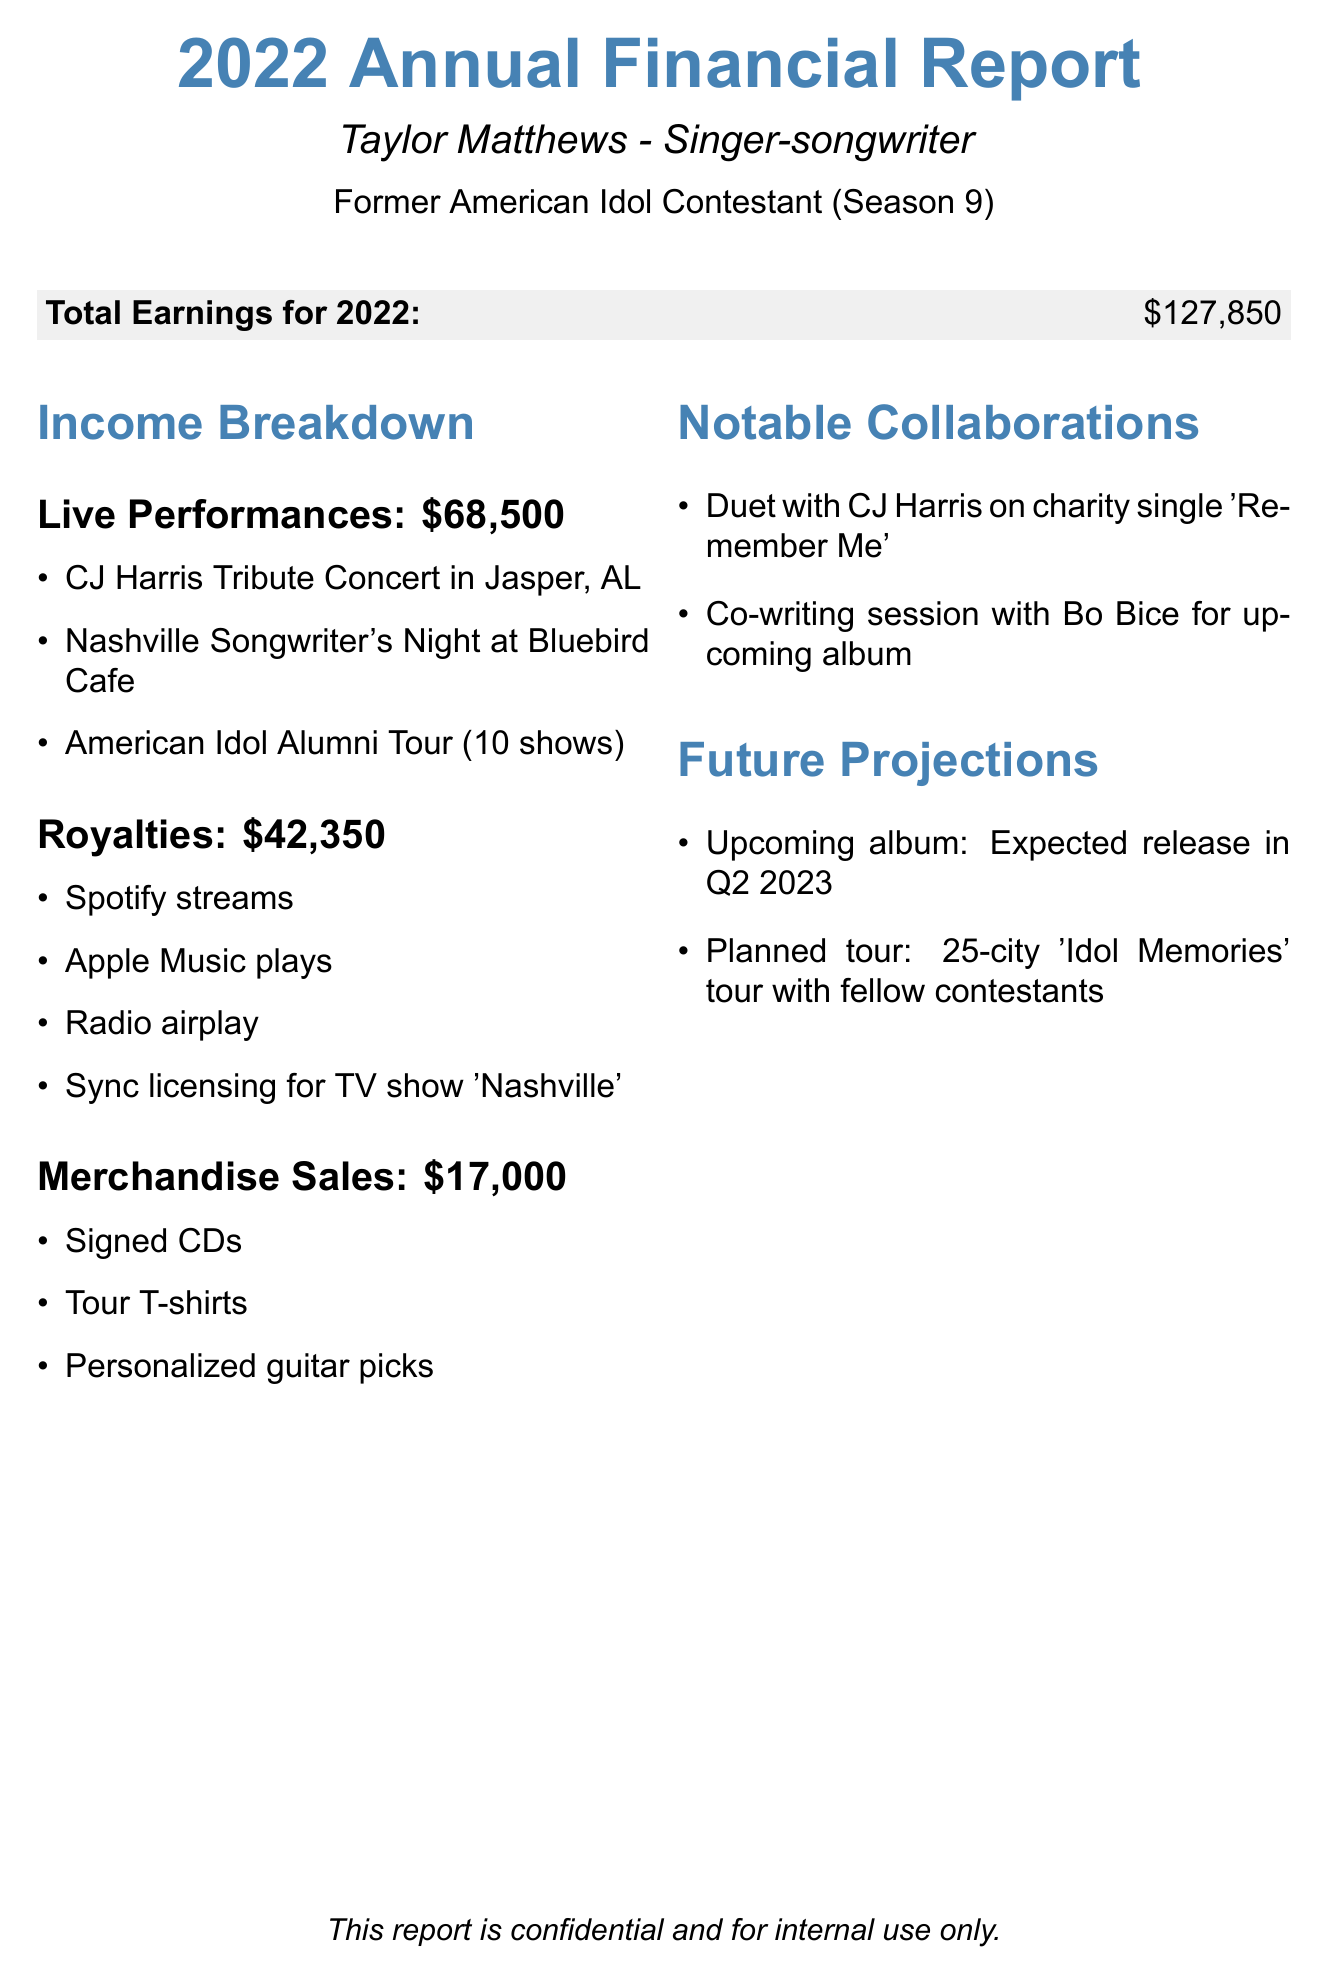What is the total earnings for 2022? The total earnings is explicitly mentioned in the document as $127,850.
Answer: $127,850 How much was earned from live performances? The live performances section states the total earnings from this category as $68,500.
Answer: $68,500 What were the notable events from live performances? The document lists specific notable events including the CJ Harris Tribute Concert, Nashville Songwriter's Night, and American Idol Alumni Tour.
Answer: CJ Harris Tribute Concert in Jasper, AL; Nashville Songwriter's Night at Bluebird Cafe; American Idol Alumni Tour (10 shows) What is the total income from merchandise sales? Merchandise sales total is directly provided in the document as $17,000.
Answer: $17,000 Which platforms contributed to royalties? The document explicitly lists the sources of royalties, including Spotify streams and Apple Music plays.
Answer: Spotify streams, Apple Music plays, Radio airplay, Sync licensing for TV show 'Nashville' What is the name of the charity single with CJ Harris? The collaboration section mentions the charity single as 'Remember Me.'
Answer: Remember Me When is the expected release of the upcoming album? The future projections state the expected release of the upcoming album is in Q2 2023.
Answer: Q2 2023 How many shows are planned for the upcoming tour? The planned tour section indicates that there will be a 25-city tour.
Answer: 25-city What type of merchandise items are included in sales? The document lists top merchandise items including signed CDs and tour T-shirts.
Answer: Signed CDs, Tour T-shirts, Personalized guitar picks 